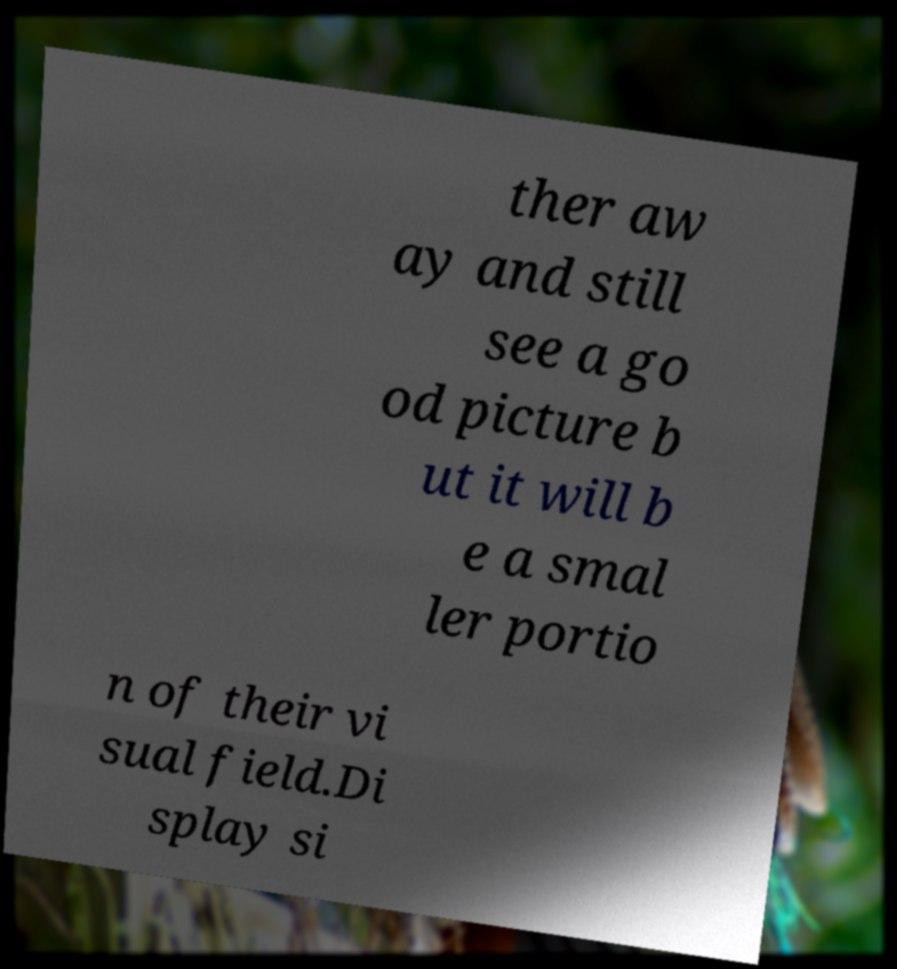For documentation purposes, I need the text within this image transcribed. Could you provide that? ther aw ay and still see a go od picture b ut it will b e a smal ler portio n of their vi sual field.Di splay si 